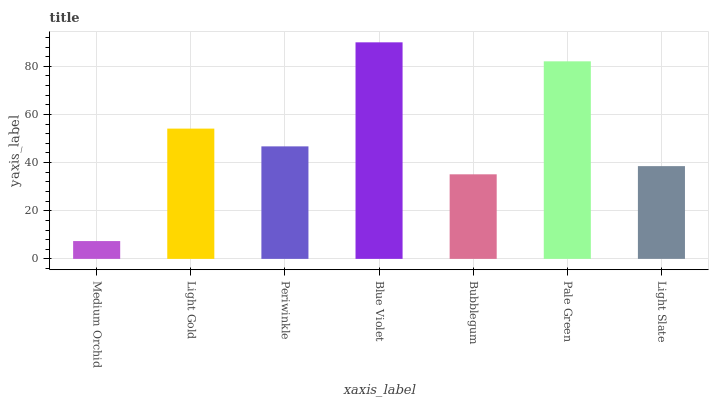Is Medium Orchid the minimum?
Answer yes or no. Yes. Is Blue Violet the maximum?
Answer yes or no. Yes. Is Light Gold the minimum?
Answer yes or no. No. Is Light Gold the maximum?
Answer yes or no. No. Is Light Gold greater than Medium Orchid?
Answer yes or no. Yes. Is Medium Orchid less than Light Gold?
Answer yes or no. Yes. Is Medium Orchid greater than Light Gold?
Answer yes or no. No. Is Light Gold less than Medium Orchid?
Answer yes or no. No. Is Periwinkle the high median?
Answer yes or no. Yes. Is Periwinkle the low median?
Answer yes or no. Yes. Is Blue Violet the high median?
Answer yes or no. No. Is Light Gold the low median?
Answer yes or no. No. 